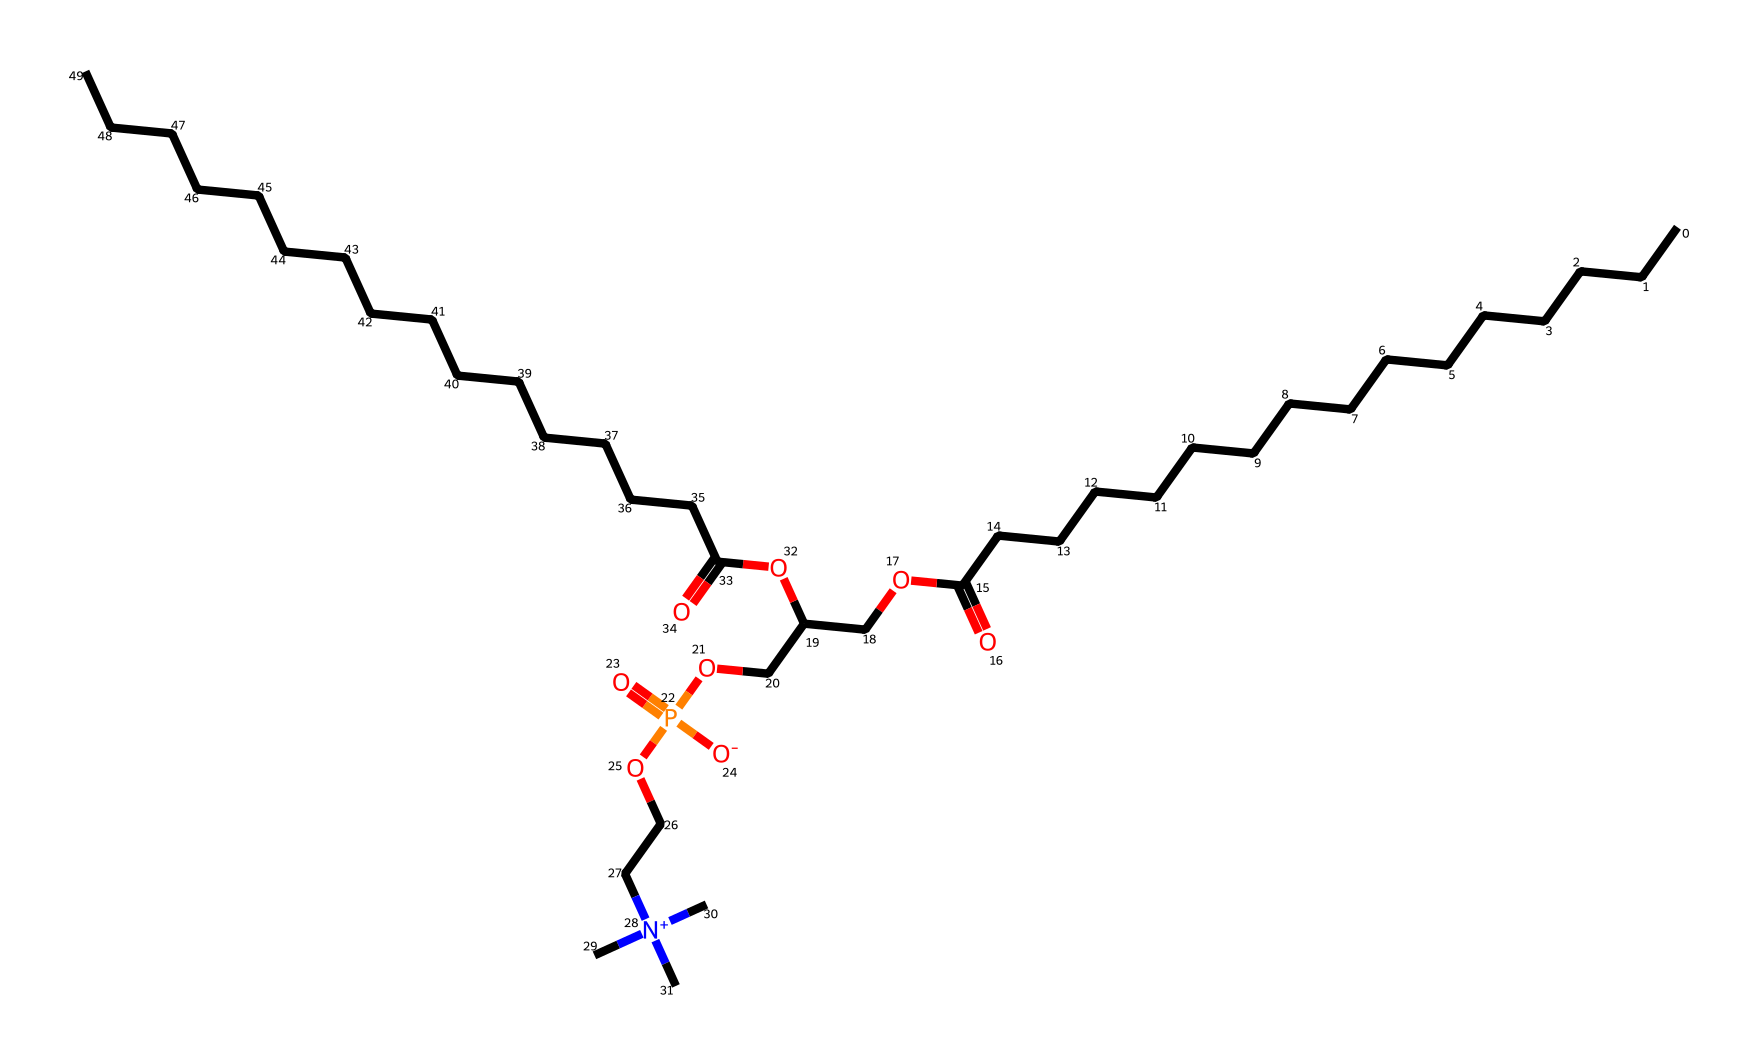What is the total number of carbon atoms in this structure? By examining the SMILES representation, we can count the 'C' characters, including those in the chains and functional groups. There are a total of 33 carbon atoms represented in this structure.
Answer: 33 How many phosphorus atoms are present in the chemical? The SMILES notation has the 'P' character indicating the presence of phosphorus. There is 1 'P' in the structure, which confirms there is one phosphorus atom.
Answer: 1 What type of functional groups are present in this compound? Analyzing the given structure, we identify carbonyl groups (C=O) from the ester functionalities and the phosphodiester (P=O) referencing the phosphorus presence. Overall, we see ester and phosphate functional groups contributing to its lipid classification.
Answer: ester, phosphate What is the significance of the nitrogen atom in this chemical? The presence of a nitrogen atom in the structure indicates there are quaternary ammonium groups, which often contribute to the surface-active properties of lipids and can enhance emulsification in therapeutic milk formulas.
Answer: quaternary ammonium Which part of the molecule contributes to its lipid properties? The long hydrocarbon chains (represented by multiple -C- segments) characterize this molecule as a lipid, as they provide hydrophobic characteristics essential for lipid behavior.
Answer: long hydrocarbon chains What kind of bonds connect the fatty acid chains to the glycerol backbone in this structure? The SMILES representation indicates ester linkages formed between fatty acid chains and the glycerol backbone, signified by the -O- connectivity when ester bonds form.
Answer: ester bonds How does the structure facilitate its role in therapeutic milk formulas? The presence of hydrophilic (from phosphate and glycerol parts) and hydrophobic (from fatty acid chains) components enables these phospholipids to improve emulsification and nutrient absorption in therapeutic milk formulas, essential for treating severe acute malnutrition.
Answer: emulsification, nutrient absorption 